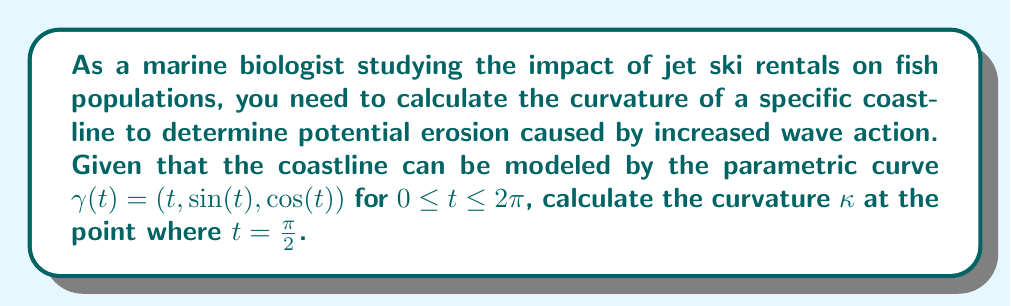Provide a solution to this math problem. To calculate the curvature of the coastline, we'll use the formula for the curvature of a parametric curve in 3D space:

$$\kappa = \frac{|\gamma'(t) \times \gamma''(t)|}{|\gamma'(t)|^3}$$

where $\gamma'(t)$ is the first derivative and $\gamma''(t)$ is the second derivative of the curve.

Step 1: Calculate $\gamma'(t)$
$$\gamma'(t) = (1, \cos(t), -\sin(t))$$

Step 2: Calculate $\gamma''(t)$
$$\gamma''(t) = (0, -\sin(t), -\cos(t))$$

Step 3: Calculate $\gamma'(t) \times \gamma''(t)$
$$\begin{align}
\gamma'(t) \times \gamma''(t) &= \begin{vmatrix}
\mathbf{i} & \mathbf{j} & \mathbf{k} \\
1 & \cos(t) & -\sin(t) \\
0 & -\sin(t) & -\cos(t)
\end{vmatrix} \\
&= (-\cos^2(t) - \sin^2(t))\mathbf{i} + (-\sin(t))\mathbf{j} + (\cos(t))\mathbf{k} \\
&= (-1)\mathbf{i} + (-\sin(t))\mathbf{j} + (\cos(t))\mathbf{k}
\end{align}$$

Step 4: Calculate $|\gamma'(t) \times \gamma''(t)|$
$$|\gamma'(t) \times \gamma''(t)| = \sqrt{(-1)^2 + (-\sin(t))^2 + (\cos(t))^2} = \sqrt{2}$$

Step 5: Calculate $|\gamma'(t)|$
$$|\gamma'(t)| = \sqrt{1^2 + \cos^2(t) + \sin^2(t)} = \sqrt{2}$$

Step 6: Calculate $\kappa$ at $t = \frac{\pi}{2}$
$$\kappa = \frac{|\gamma'(t) \times \gamma''(t)|}{|\gamma'(t)|^3} = \frac{\sqrt{2}}{(\sqrt{2})^3} = \frac{\sqrt{2}}{2\sqrt{2}} = \frac{1}{2}$$
Answer: The curvature of the coastline at $t = \frac{\pi}{2}$ is $\kappa = \frac{1}{2}$. 